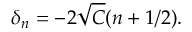Convert formula to latex. <formula><loc_0><loc_0><loc_500><loc_500>\delta _ { n } = - 2 \sqrt { C } ( n + 1 / 2 ) .</formula> 